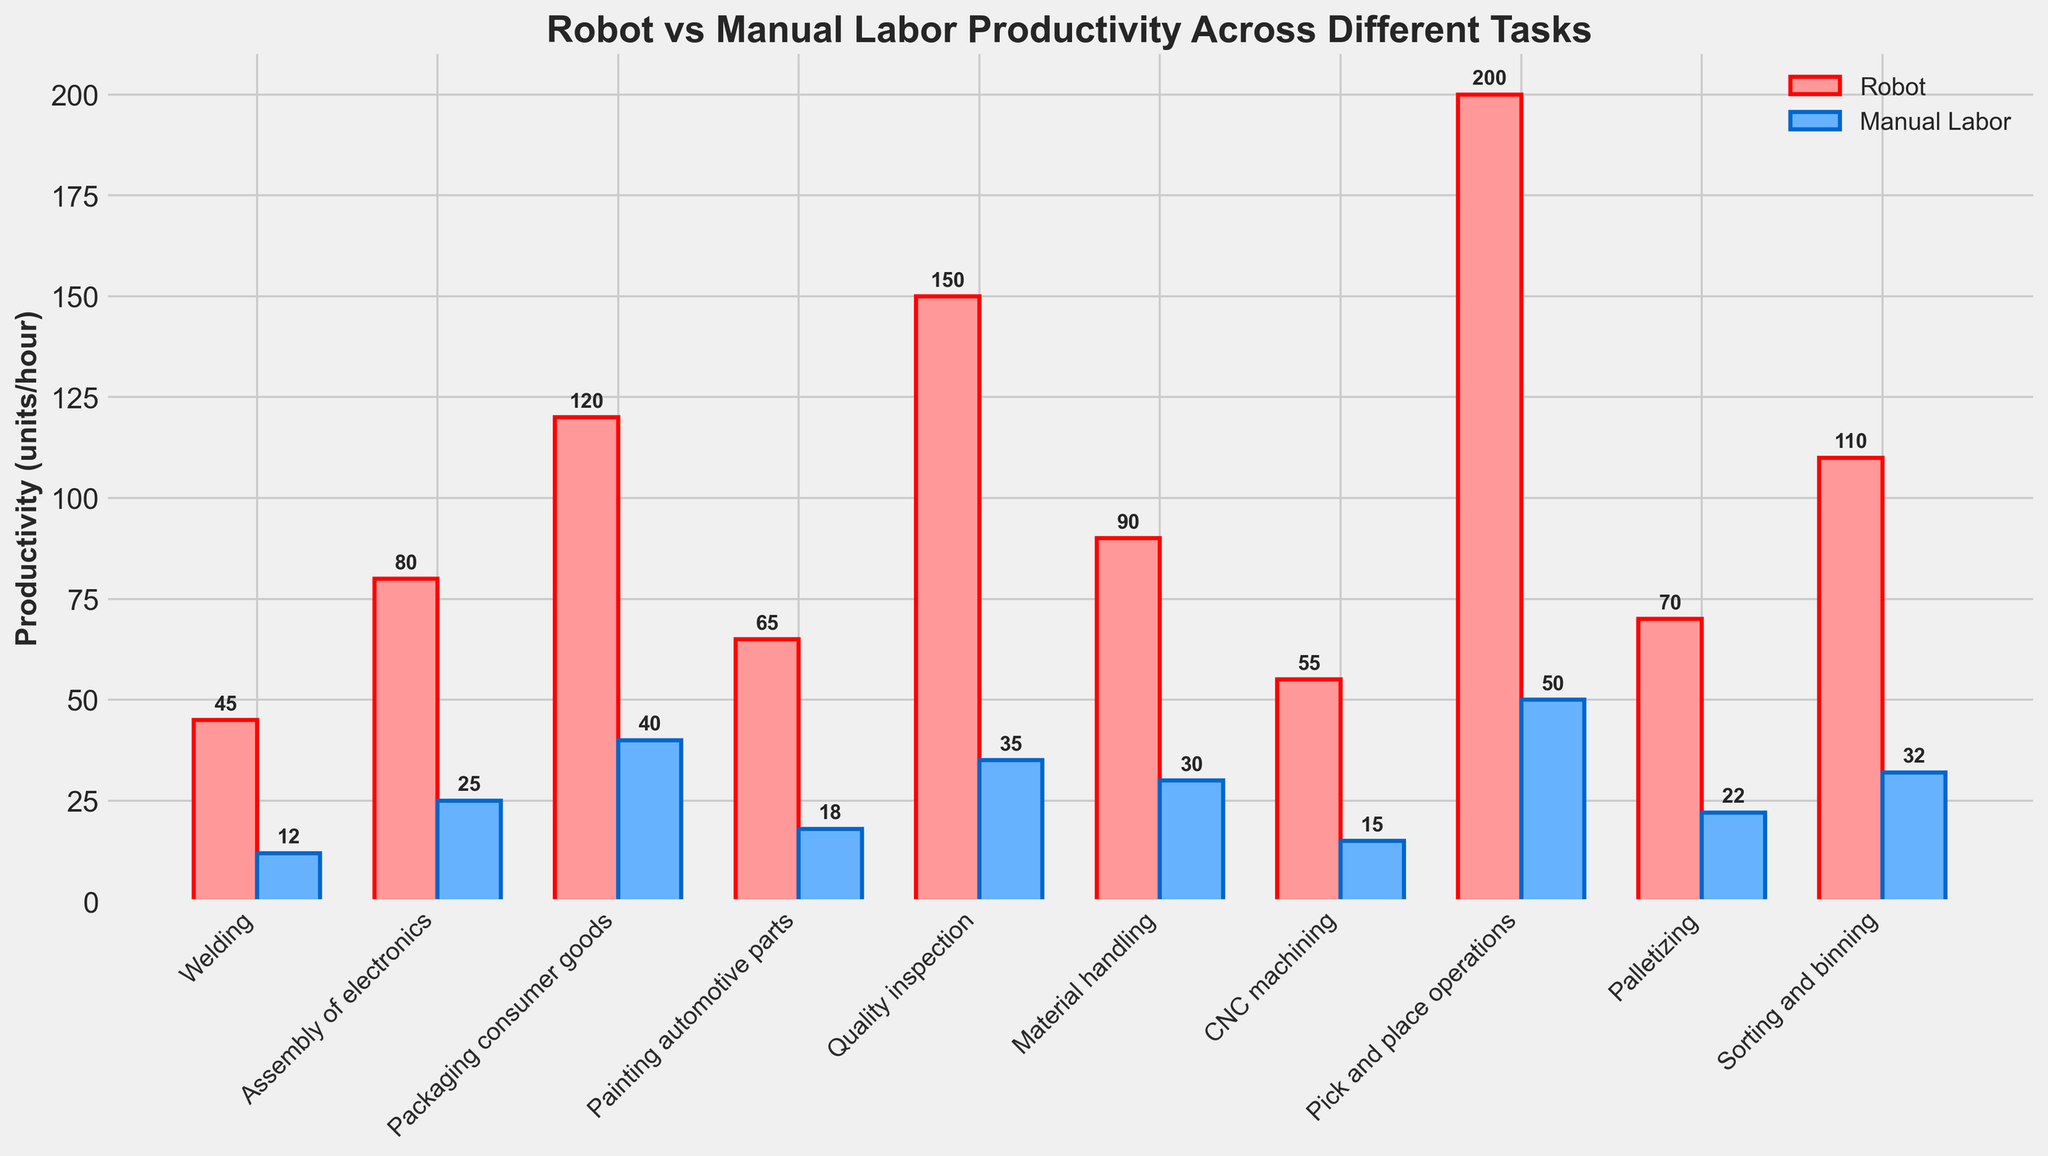What is the productivity rate of robots in the task of Welding compared to manual labor? The productivity rate of robots in the task of Welding is indicated by the height of the red bar, while the productivity rate of manual labor is shown by the height of the blue bar. According to the figure, the productivity rate of robots in Welding is 45 units/hour compared to 12 units/hour for manual labor.
Answer: Robots: 45 units/hour, Manual labor: 12 units/hour Which task shows the highest productivity rate for robots? The blue bar representing the productivity rate of robots is highest for the task labeled Pick and place operations, indicating that this task has the highest productivity rate for robots.
Answer: Pick and place operations: 200 units/hour How much more productive are robots than manual labor in the task of Packaging consumer goods? By subtracting the productivity rate of manual labor (blue bar) from that of robots (red bar) for the task of Packaging consumer goods, we find the difference. Robots show 120 units/hour, while manual labor shows 40 units/hour. The difference is 120 - 40 = 80 units/hour.
Answer: 80 units/hour What is the average productivity rate of robots across all tasks? Add up the productivity rates of robots for all tasks and divide by the number of tasks. The sum is 45 + 80 + 120 + 65 + 150 + 90 + 55 + 200 + 70 + 110 = 985 units/hour. With 10 tasks, the average productivity rate is 985 / 10 = 98.5 units/hour.
Answer: 98.5 units/hour Which task has the smallest difference in productivity rates between robots and manual labor? To find the smallest difference, calculate the difference for each task and compare them. The differences are as follows: Welding (33), Assembly of electronics (55), Packaging consumer goods (80), Painting automotive parts (47), Quality inspection (115), Material handling (60), CNC machining (40), Pick and place operations (150), Palletizing (48), Sorting and binning (78). The smallest difference is for Welding (45 - 12 = 33 units/hour).
Answer: Welding: 33 units/hour In which task do robots outperform manual labor by the smallest margin? To find the task where robots outperform manual labor by the smallest margin, examine the smallest difference between the heights of the red and blue bars for each task. By inspecting the differences calculated earlier, Welding has the smallest margin of 33 units/hour.
Answer: Welding: 33 units/hour How does the productivity rate of robots in Quality inspection compare to Painting automotive parts? Compare the heights of the red bars for the tasks Quality inspection and Painting automotive parts. According to the figure, Quality inspection has a productivity rate of 150 units/hour, and Painting automotive parts has 65 units/hour.
Answer: Robots: Quality inspection: 150 units/hour, Painting automotive parts: 65 units/hour What is the combined productivity rate of robots and manual labor for Sorting and binning? Add the productivity rates of robots and manual labor for the task Sorting and binning. Robots show 110 units/hour, and manual labor shows 32 units/hour. The combined rate is 110 + 32 = 142 units/hour.
Answer: 142 units/hour In which task does manual labor have the highest productivity rate, and what is that rate? The highest productivity rate for manual labor can be identified by the tallest blue bar. The tallest blue bar is for Pick and place operations with a productivity rate of 50 units/hour.
Answer: Pick and place operations: 50 units/hour 